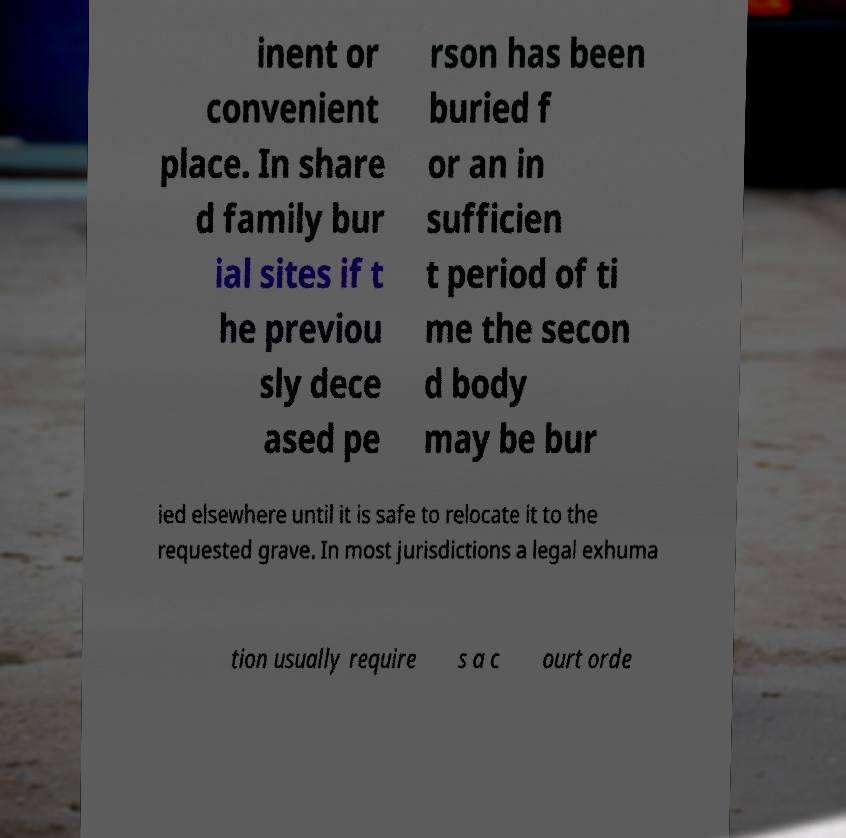Can you read and provide the text displayed in the image?This photo seems to have some interesting text. Can you extract and type it out for me? inent or convenient place. In share d family bur ial sites if t he previou sly dece ased pe rson has been buried f or an in sufficien t period of ti me the secon d body may be bur ied elsewhere until it is safe to relocate it to the requested grave. In most jurisdictions a legal exhuma tion usually require s a c ourt orde 